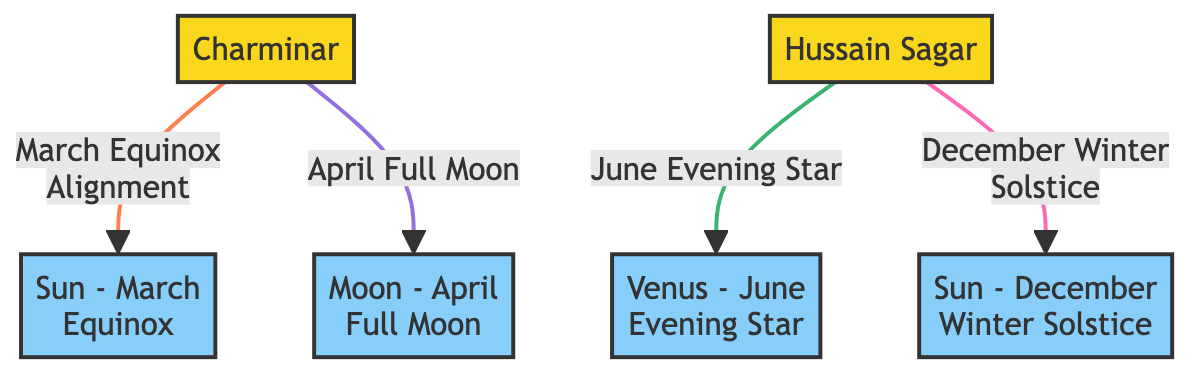What is the first landmark listed in the diagram? The diagram lists the Charminar as the first landmark. It is labeled with the number "1" and is represented in a yellow color along with "Charminar" text.
Answer: Charminar How many celestial bodies are shown in the diagram? The diagram includes four celestial bodies: Sun during March Equinox, Moon during April Full Moon, Venus during June Evening Star, and Sun during December Winter Solstice. This totals to four distinct nodes.
Answer: Four What alignment is shown for Charminar in April? The alignment for Charminar is associated with the April Full Moon. It connects the Charminar to the Moon node in the diagram.
Answer: April Full Moon Which landmark is aligned with Venus in June? The Hussain Sagar is aligned with Venus in June as specified in the diagram connecting to the Evening Star node labeled for June.
Answer: Hussain Sagar Which month corresponds to the alignment of the Sun with Charminar? The alignment of the Sun with Charminar corresponds to the March Equinox. This is clearly marked in the diagram with a connection from Charminar to the Sun node for March.
Answer: March Equinox What color represents the celestial bodies in this diagram? The celestial bodies are represented with a sky blue color (hex code #87cefa) in the diagram, distinguishing them from the landmarks.
Answer: Sky blue How many total edges connect celestial bodies to landmarks in the diagram? There are four edges in total connecting celestial bodies to landmarks: one from Charminar to Sun (March), one from Charminar to Moon (April), one from Hussain Sagar to Venus (June), and one from Hussain Sagar to Sun (December).
Answer: Four Which landmark has the most alignments shown in the diagram? The Charminar has two alignments shown in the diagram: one with the Sun in March and another with the Moon in April. Conversely, the Hussain Sagar only has the alignments with Venus and the Sun.
Answer: Charminar What is the significance of the December Sun alignment in the context of landmarks? The December Sun alignment specifically connects with the Hussain Sagar in the context of the diagram indicating its position during the Winter Solstice, providing insights into seasonal alignment.
Answer: Winter Solstice 